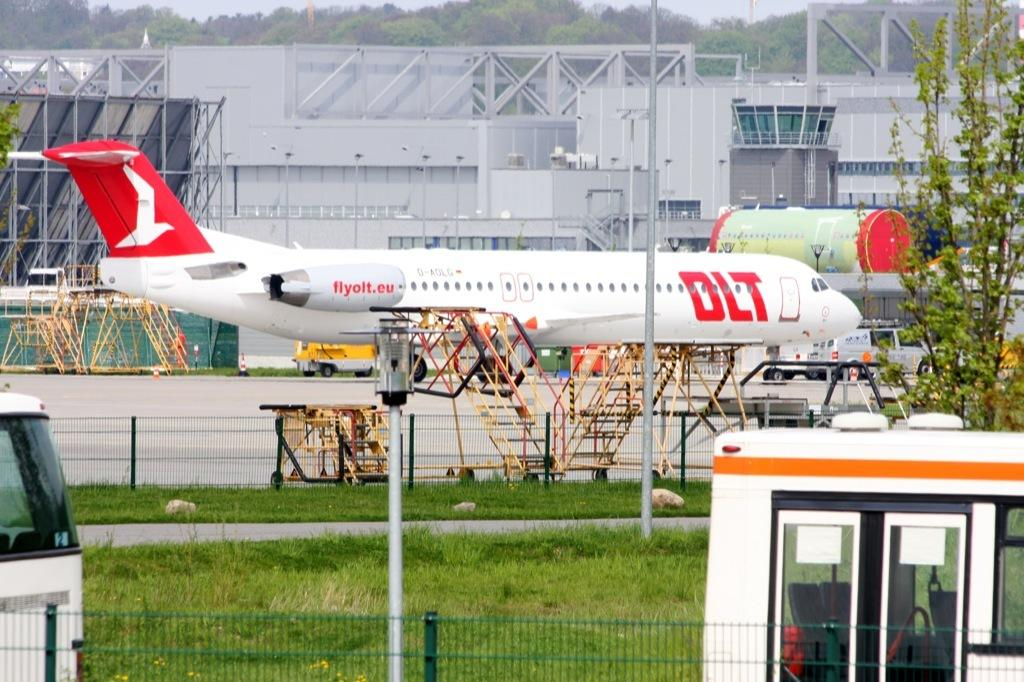Provide a one-sentence caption for the provided image. A white and red airplane with the words flyolt.eu on it. 